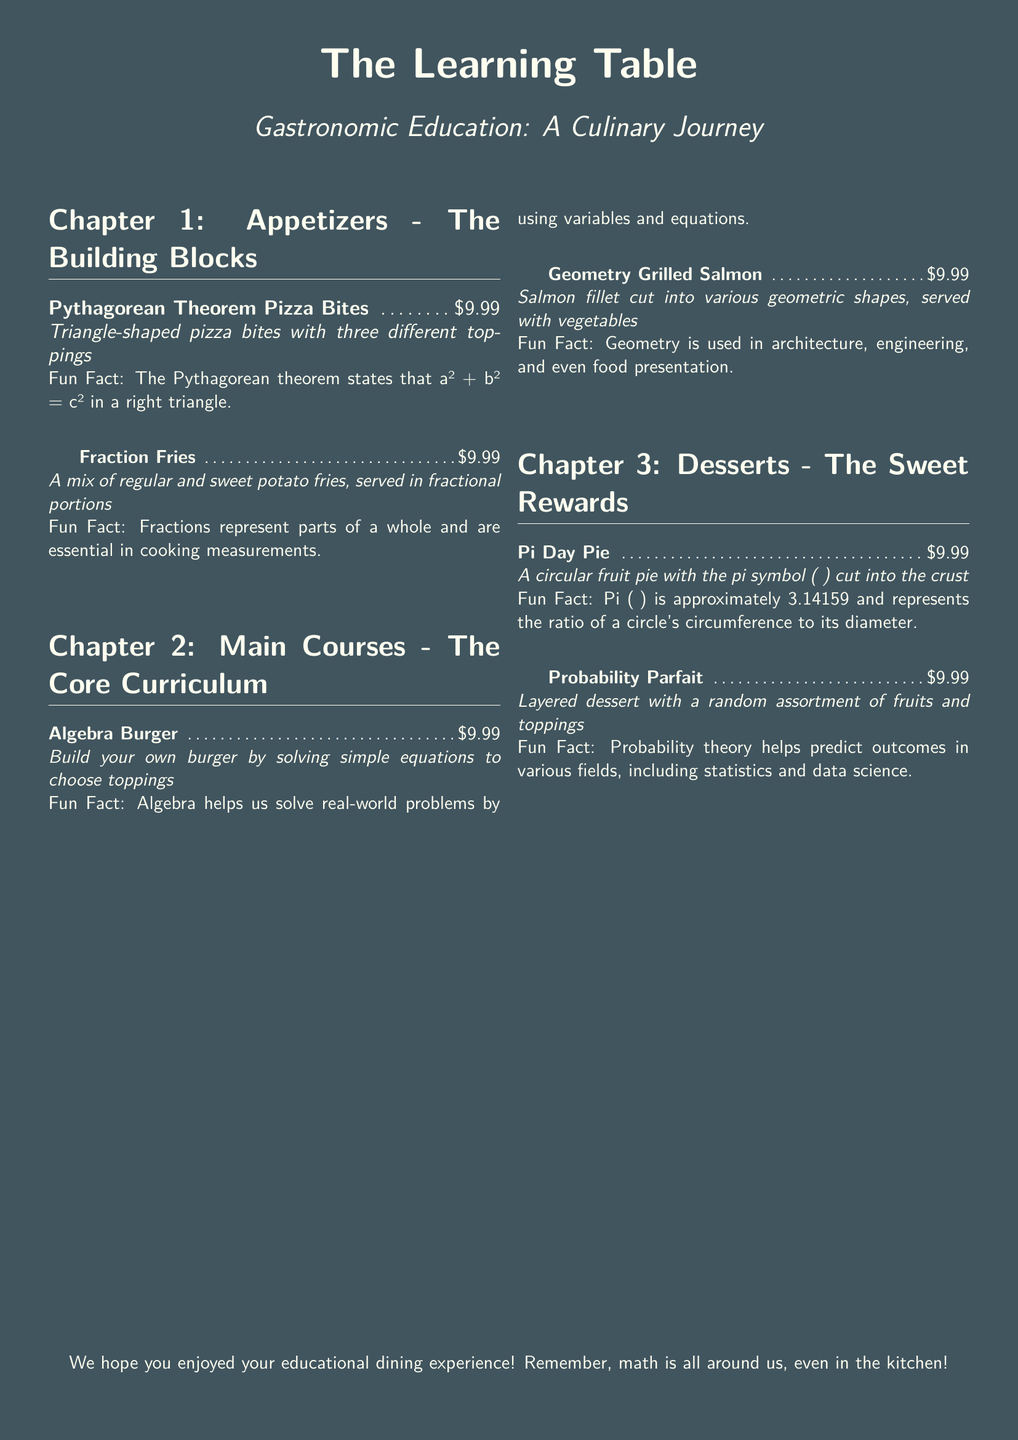What is the name of the restaurant? The name of the restaurant is prominently featured at the top of the document.
Answer: The Learning Table How many appetizers are listed in the menu? The document contains a section specifically for appetizers, and counting them provides the answer.
Answer: 2 Which dessert has a mathematical symbol in its name? The dessert section lists a pie that includes a mathematical symbol, which is noted in its description.
Answer: Pi Day Pie What is one fun fact about the Algebra Burger? The fun fact associated with the Algebra Burger is included in its description.
Answer: Algebra helps us solve real-world problems by using variables and equations What are the two types of fries mentioned in the menu? The menu provides details about the types of fries served with the Fraction Fries item.
Answer: regular and sweet potato fries Which main course is shaped into geometric forms? The menu item specifically describes a dish cut into various geometric shapes.
Answer: Geometry Grilled Salmon What is the price of each menu item? The price is stated uniformly across all menu items in the document.
Answer: $9.99 What chapter encompasses the sweet treats? The document is structured into chapters, and the relevant chapter is identified as one that includes desserts.
Answer: Chapter 3: Desserts - The Sweet Rewards 